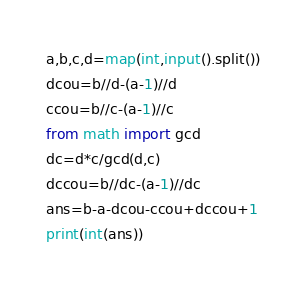Convert code to text. <code><loc_0><loc_0><loc_500><loc_500><_Python_>a,b,c,d=map(int,input().split())
dcou=b//d-(a-1)//d
ccou=b//c-(a-1)//c
from math import gcd
dc=d*c/gcd(d,c)
dccou=b//dc-(a-1)//dc
ans=b-a-dcou-ccou+dccou+1
print(int(ans))</code> 